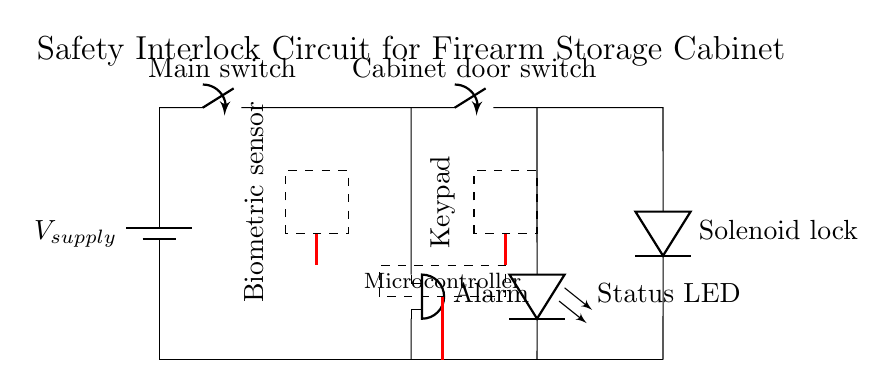What is the main function of the solenoid lock? The solenoid lock serves to secure the firearm storage cabinet; it is activated when the interlock circuit is complete, allowing access.
Answer: Secure storage What type of alarm is present in the circuit? The circuit includes a buzzer, which is responsible for sounding an alarm when unauthorized access is attempted or if the cabinet door is opened without proper authentication.
Answer: Buzzer How many switches are in the circuit? There are two switches: one main switch and one cabinet door switch, which control the flow of current and the locking mechanism.
Answer: Two What is the role of the biometric sensor in the circuit? The biometric sensor is used to verify the identity of the user before allowing the solenoid lock to disengage and the cabinet to open, enhancing security.
Answer: Identity verification Which component indicates the status of the interlock circuit? The status LED indicates whether the circuit is active or inactive, providing a visual representation of the state of the cabinet's security system.
Answer: Status LED What triggers the alarm in this circuit? The alarm is triggered when the cabinet door switch is activated, indicating that the door has been opened, which could suggest unauthorized access.
Answer: Cabinet door switch What needs to happen for the solenoid lock to activate? For the solenoid lock to activate, both the main switch must be closed and the cabinet door switch must be closed, allowing current to flow through the circuit.
Answer: Both switches closed 